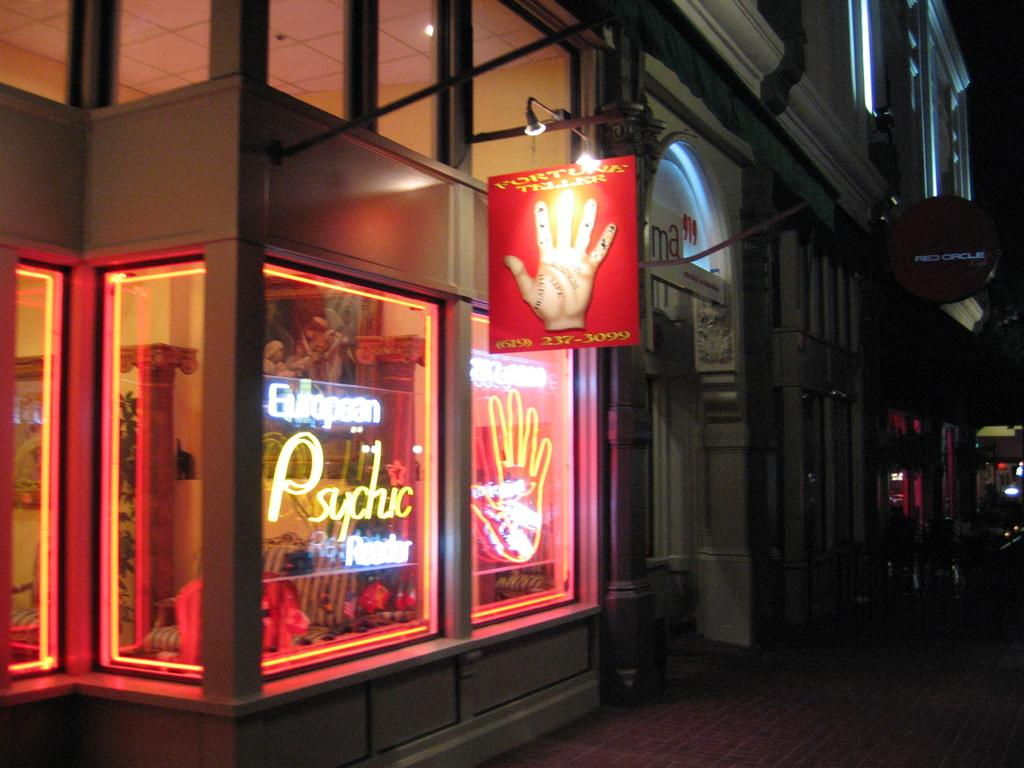What type of establishment is shown in the image? There is a store in the image. What materials are used in the construction of the store? Boards, lights, a wall, a door, a roof, and glass are present in the image. What can be seen at the bottom of the image? A road is visible at the bottom of the image. What is visible at the top right corner of the image? The sky is visible at the top right corner of the image. What type of scarf is the achiever wearing in the image? There is no achiever or scarf present in the image; it features a store with various construction materials and a road and sky in the background. 